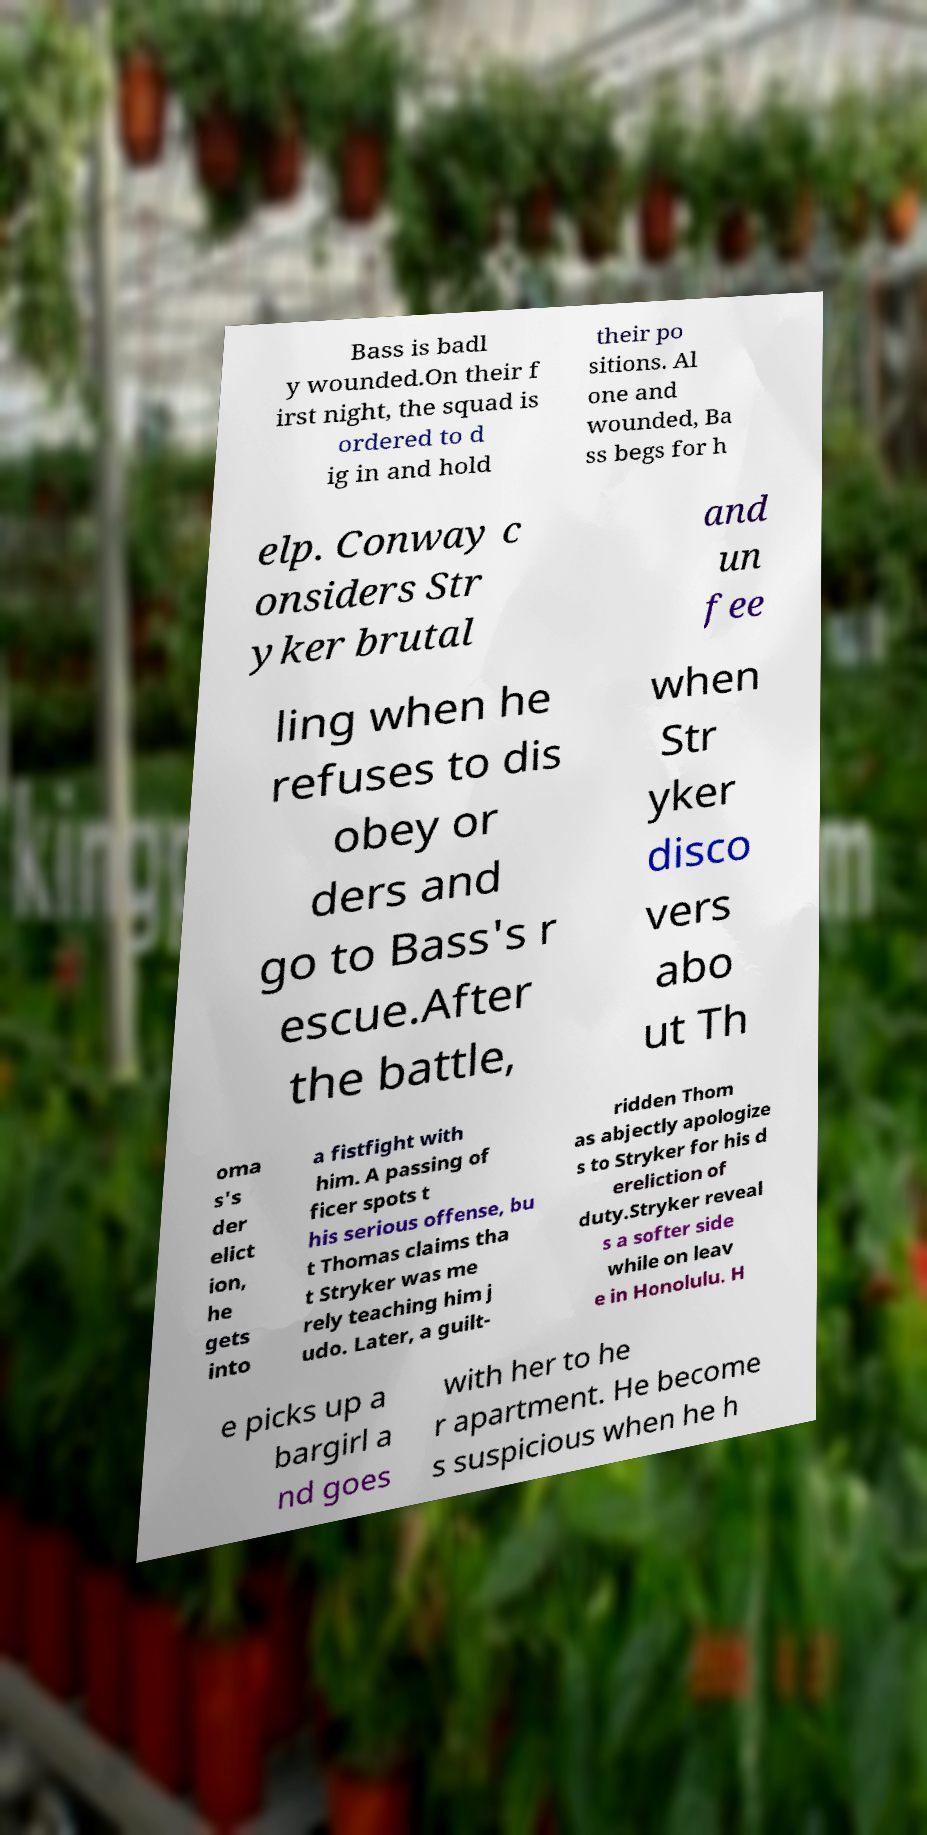Please identify and transcribe the text found in this image. Bass is badl y wounded.On their f irst night, the squad is ordered to d ig in and hold their po sitions. Al one and wounded, Ba ss begs for h elp. Conway c onsiders Str yker brutal and un fee ling when he refuses to dis obey or ders and go to Bass's r escue.After the battle, when Str yker disco vers abo ut Th oma s's der elict ion, he gets into a fistfight with him. A passing of ficer spots t his serious offense, bu t Thomas claims tha t Stryker was me rely teaching him j udo. Later, a guilt- ridden Thom as abjectly apologize s to Stryker for his d ereliction of duty.Stryker reveal s a softer side while on leav e in Honolulu. H e picks up a bargirl a nd goes with her to he r apartment. He become s suspicious when he h 